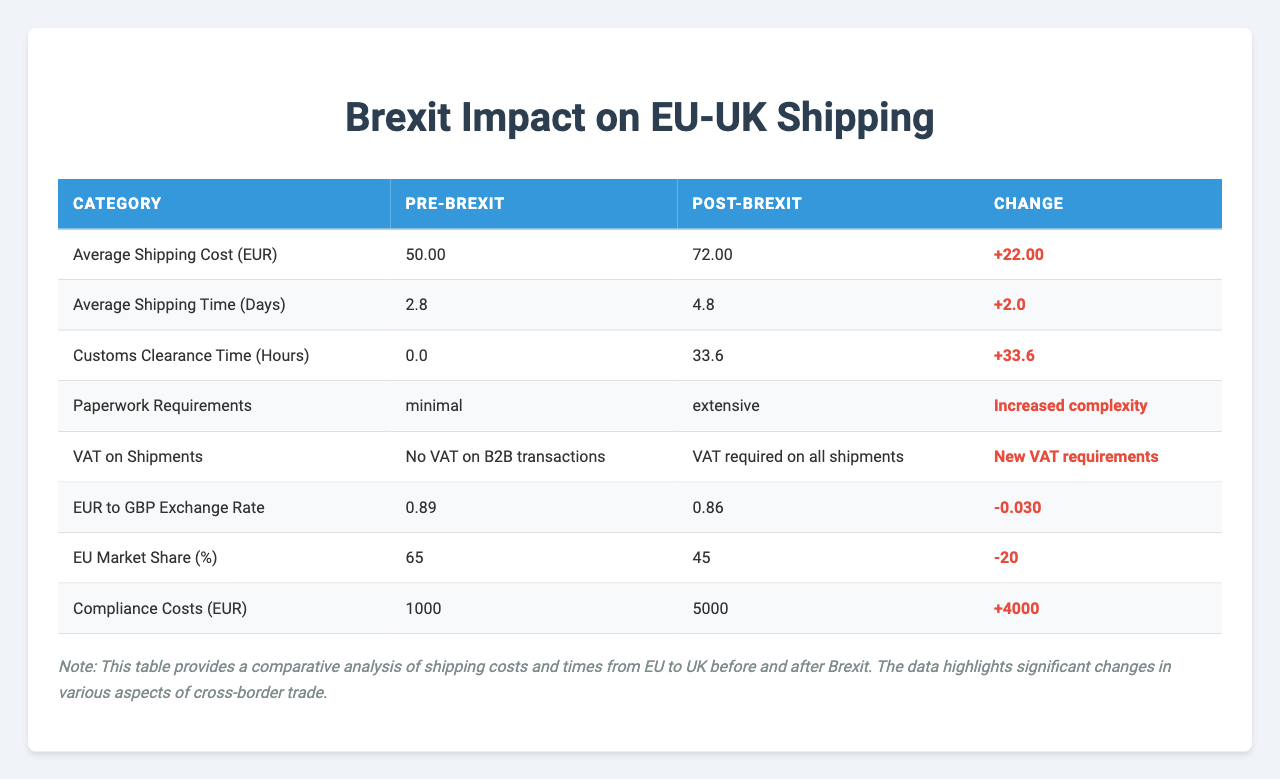What was the average shipping cost in EUR before Brexit? The average shipping cost before Brexit can be calculated by summing the pre-Brexit average shipping costs (45 + 50 + 48 + 52 + 55) which equals 250, and dividing by 5 (the number of shipping companies), resulting in 50.
Answer: 50 What is the average shipping cost in EUR after Brexit? The average shipping cost after Brexit can be calculated by summing the post-Brexit average shipping costs (65 + 72 + 68 + 75 + 80) which equals 360, and dividing by 5, yielding 72.
Answer: 72 How much did the average shipping cost increase after Brexit? The increase in average shipping cost is found by subtracting the pre-Brexit average (50) from the post-Brexit average (72), which shows an increase of 22.
Answer: 22 What are the customs clearance times in hours before Brexit? The customs clearance time before Brexit is the average of the pre-Brexit customs clearance times, which is 0 hours across all shipping companies.
Answer: 0 What are the customs clearance times in hours after Brexit? The average customs clearance time after Brexit can be derived from the post-Brexit customs data (24, 36, 24, 36, 48), summing them gives 168 hours, which divided by 5 results in 33.6 hours, so we can round it to 34 hours.
Answer: 34 What was the change in average shipping time from before to after Brexit? To find the change, subtract the average shipping time before Brexit (2.8 days) from the average shipping time after Brexit (4.8 days). The result is an increase of 2 days.
Answer: 2 Was there an increase in paperwork requirements after Brexit? Yes, the table indicates that paperwork requirements changed from minimal to extensive after Brexit, confirming that the complexity increased.
Answer: Yes What was the pre-Brexit exchange rate for EUR to GBP? According to the table, the pre-Brexit exchange rate for EUR to GBP was 0.89.
Answer: 0.89 What was the post-Brexit exchange rate for EUR to GBP? The post-Brexit exchange rate for EUR to GBP, as per the table, is 0.86.
Answer: 0.86 How much did compliance costs increase after Brexit? The increase in compliance costs can be found by subtracting the pre-Brexit compliance costs (1000 EUR) from the post-Brexit compliance costs (5000 EUR), resulting in an increase of 4000 EUR.
Answer: 4000 What is the percentage of EU market share before and after Brexit? The pre-Brexit EU market share is 65% and the post-Brexit share is 45%. Thus, there was a decrease of 20% in market share.
Answer: 20% 